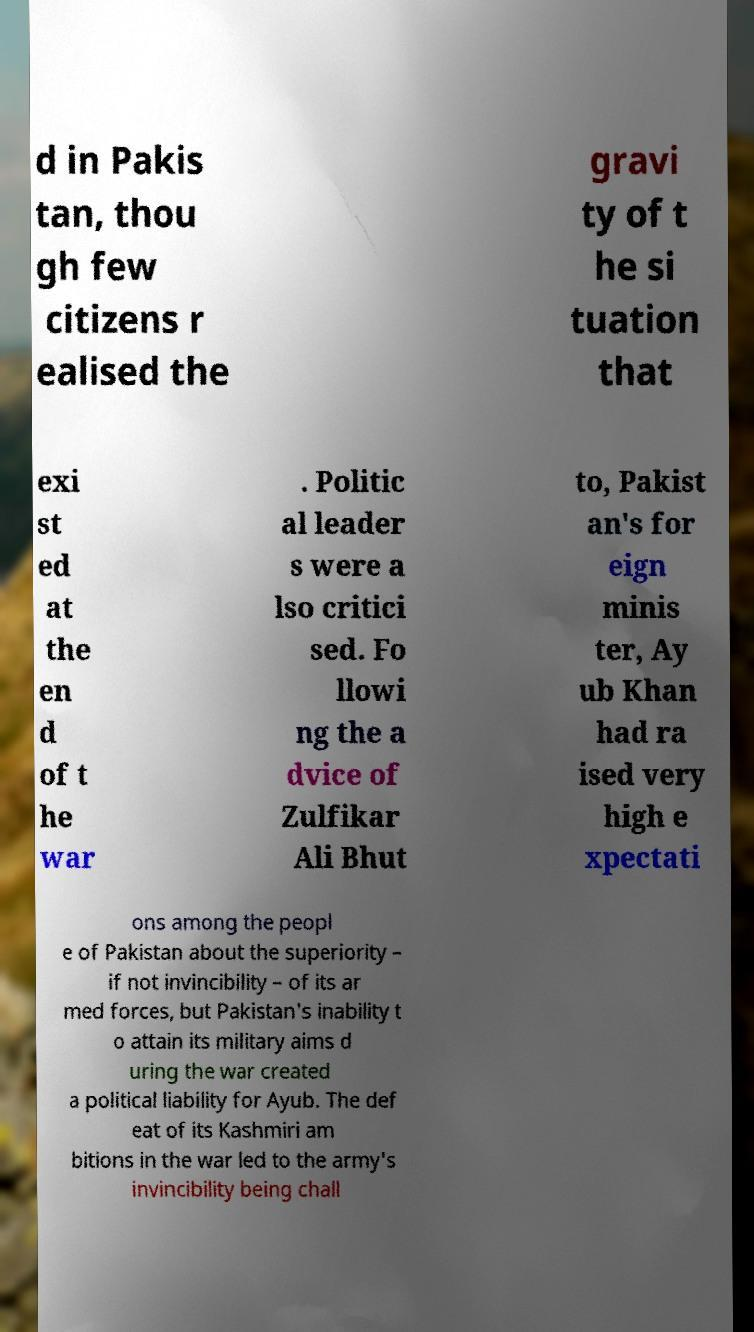For documentation purposes, I need the text within this image transcribed. Could you provide that? d in Pakis tan, thou gh few citizens r ealised the gravi ty of t he si tuation that exi st ed at the en d of t he war . Politic al leader s were a lso critici sed. Fo llowi ng the a dvice of Zulfikar Ali Bhut to, Pakist an's for eign minis ter, Ay ub Khan had ra ised very high e xpectati ons among the peopl e of Pakistan about the superiority – if not invincibility – of its ar med forces, but Pakistan's inability t o attain its military aims d uring the war created a political liability for Ayub. The def eat of its Kashmiri am bitions in the war led to the army's invincibility being chall 